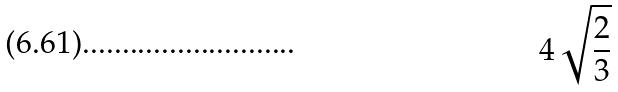<formula> <loc_0><loc_0><loc_500><loc_500>4 \sqrt { \frac { 2 } { 3 } }</formula> 